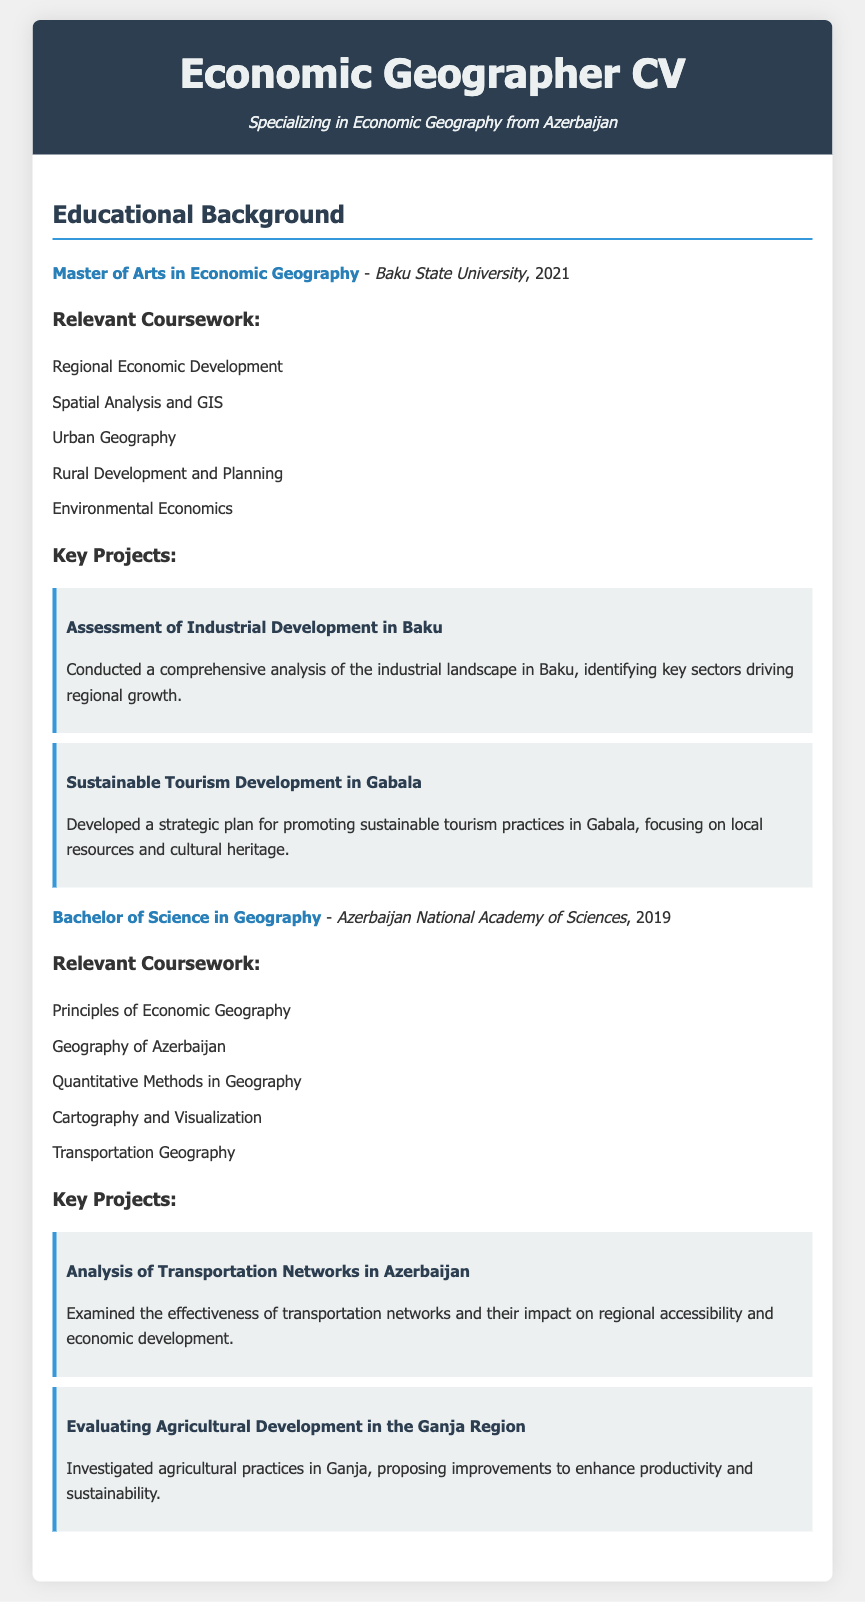What is the highest degree obtained? The highest degree mentioned in the document is the Master's Degree in Economic Geography.
Answer: Master of Arts in Economic Geography Which university awarded the bachelor's degree? The document specifies that the Bachelor of Science in Geography was awarded by Azerbaijan National Academy of Sciences.
Answer: Azerbaijan National Academy of Sciences What year was the Master’s degree completed? The document states that the Master of Arts in Economic Geography was completed in 2021.
Answer: 2021 Name one relevant coursework from the Master's degree. The question asks for any coursework from the Master's section; the document lists multiple courses, one of which is Regional Economic Development.
Answer: Regional Economic Development What project focused on tourism development? The document includes a project specifically about tourism development, titled "Sustainable Tourism Development in Gabala."
Answer: Sustainable Tourism Development in Gabala How many key projects are listed under the Bachelor's degree? The document indicates that there are two key projects mentioned under the Bachelor's degree section.
Answer: 2 Identify a key theme from the relevant coursework in the Bachelor's degree. The coursework includes topics about geography in Azerbaijan and economic principles, indicating that a key theme is the relationship between geography and economy in the context of Azerbaijan.
Answer: Geography of Azerbaijan What project involved transportation networks? The document specifies a project titled "Analysis of Transportation Networks in Azerbaijan."
Answer: Analysis of Transportation Networks in Azerbaijan Which project analyzed agricultural practices? The document details a project named "Evaluating Agricultural Development in the Ganja Region."
Answer: Evaluating Agricultural Development in the Ganja Region 